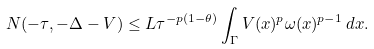<formula> <loc_0><loc_0><loc_500><loc_500>N ( - \tau , - \Delta - V ) \leq L \tau ^ { - p ( 1 - \theta ) } \int _ { \Gamma } V ( x ) ^ { p } \omega ( x ) ^ { p - 1 } \, d x .</formula> 